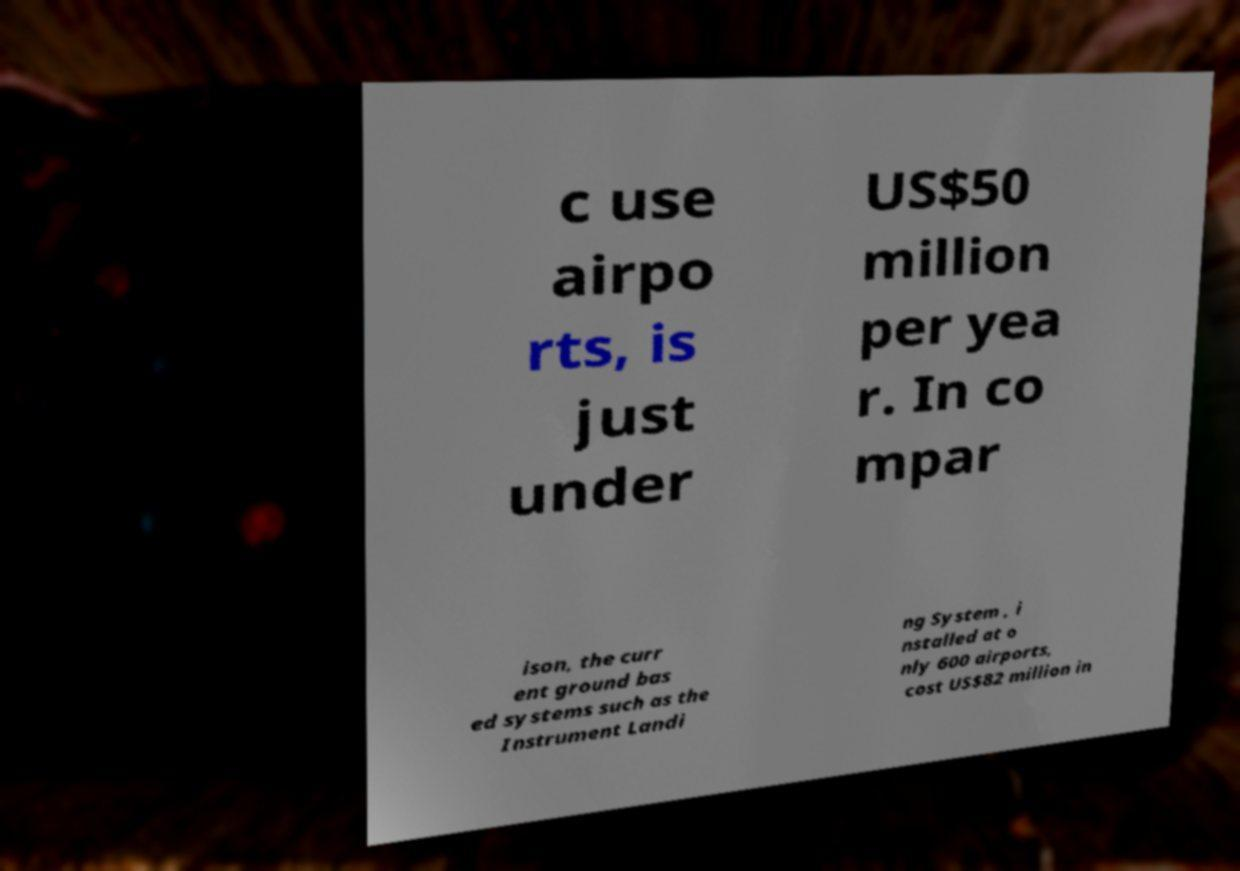Please identify and transcribe the text found in this image. c use airpo rts, is just under US$50 million per yea r. In co mpar ison, the curr ent ground bas ed systems such as the Instrument Landi ng System , i nstalled at o nly 600 airports, cost US$82 million in 